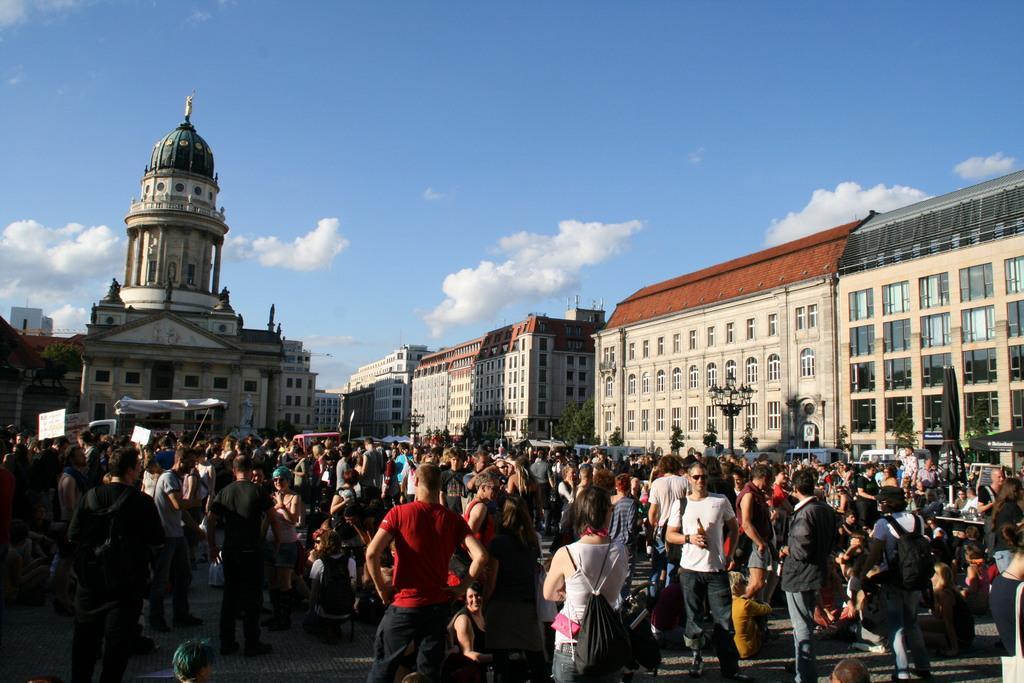Please provide a concise description of this image. In the picture I can see a group of people are standing on the ground. In the background I can see buildings, street lights, the sky and some other objects. 